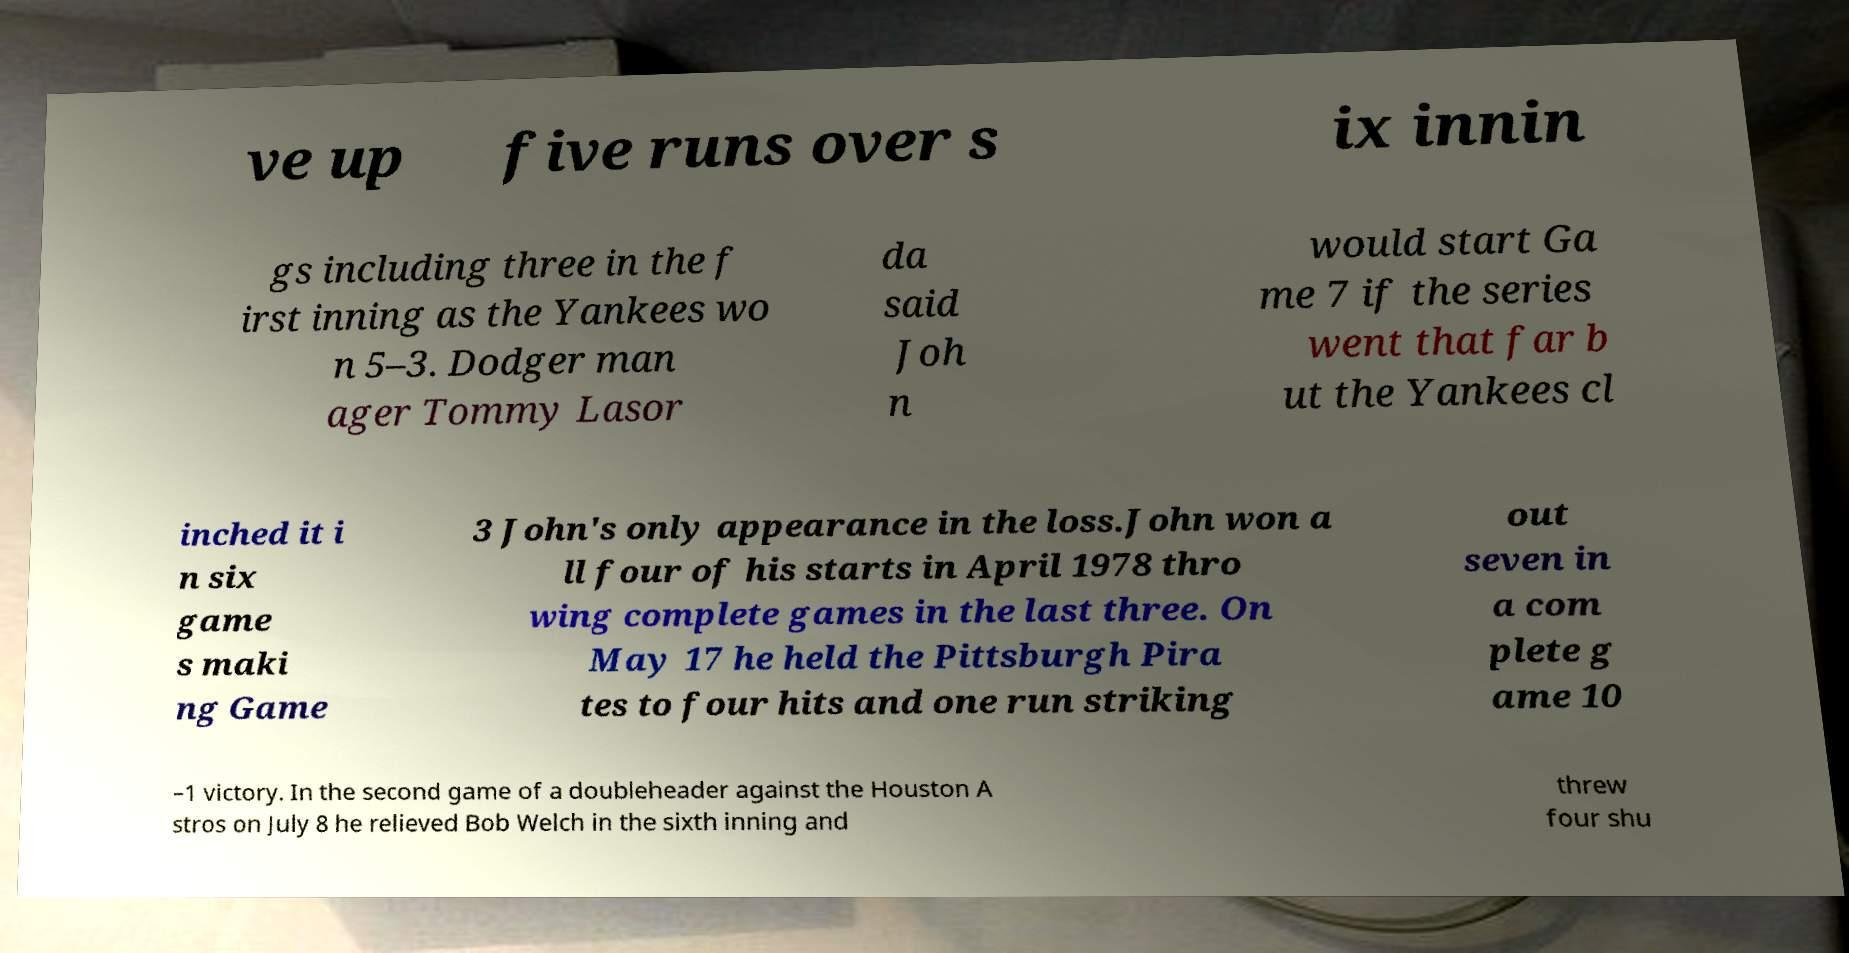Can you read and provide the text displayed in the image?This photo seems to have some interesting text. Can you extract and type it out for me? ve up five runs over s ix innin gs including three in the f irst inning as the Yankees wo n 5–3. Dodger man ager Tommy Lasor da said Joh n would start Ga me 7 if the series went that far b ut the Yankees cl inched it i n six game s maki ng Game 3 John's only appearance in the loss.John won a ll four of his starts in April 1978 thro wing complete games in the last three. On May 17 he held the Pittsburgh Pira tes to four hits and one run striking out seven in a com plete g ame 10 –1 victory. In the second game of a doubleheader against the Houston A stros on July 8 he relieved Bob Welch in the sixth inning and threw four shu 